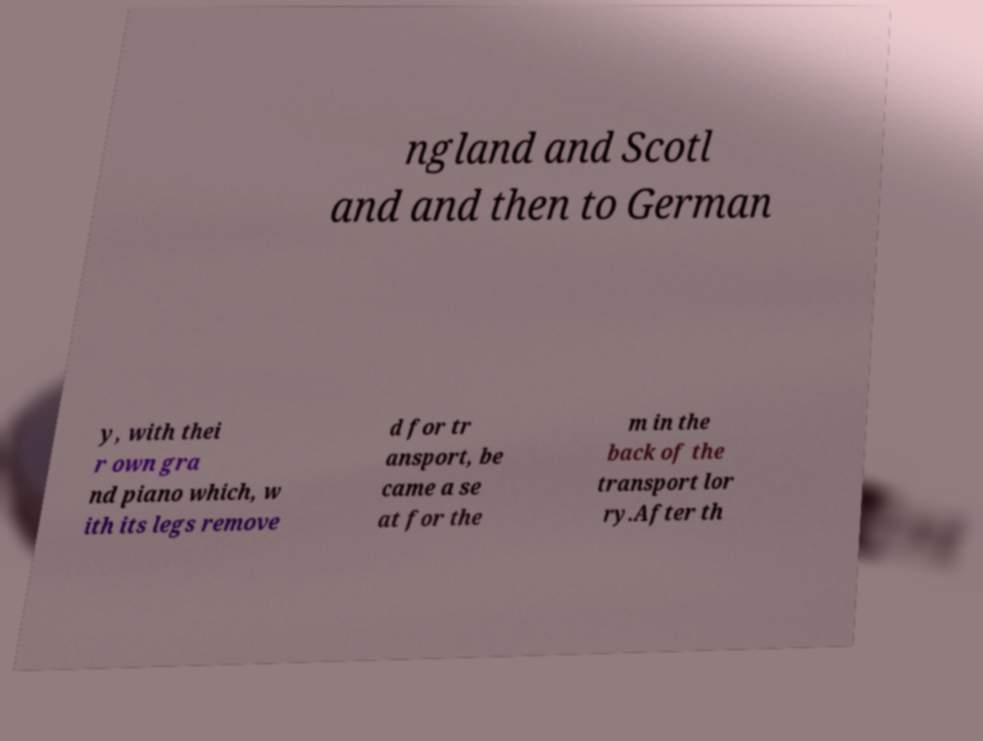Can you read and provide the text displayed in the image?This photo seems to have some interesting text. Can you extract and type it out for me? ngland and Scotl and and then to German y, with thei r own gra nd piano which, w ith its legs remove d for tr ansport, be came a se at for the m in the back of the transport lor ry.After th 